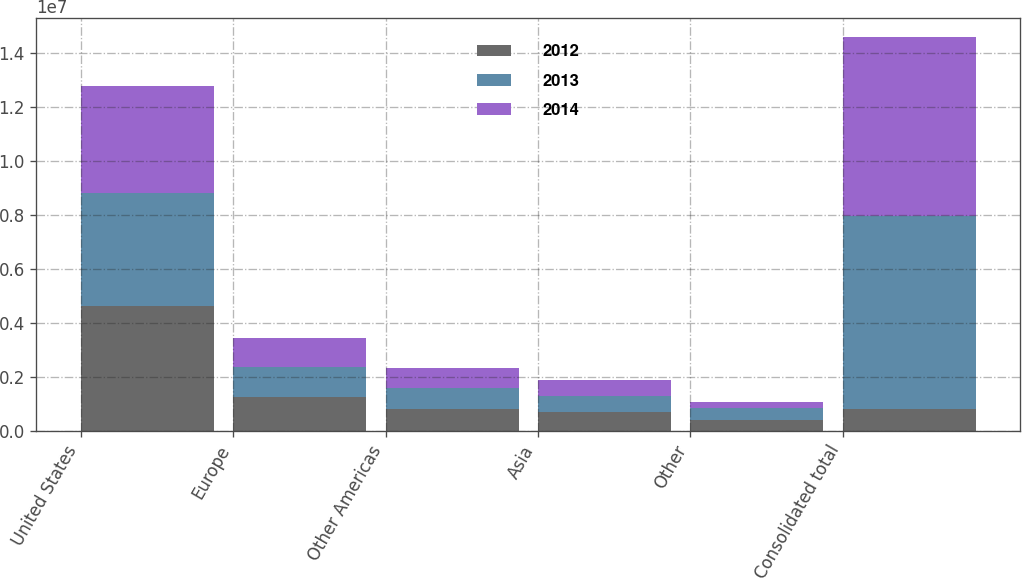Convert chart to OTSL. <chart><loc_0><loc_0><loc_500><loc_500><stacked_bar_chart><ecel><fcel>United States<fcel>Europe<fcel>Other Americas<fcel>Asia<fcel>Other<fcel>Consolidated total<nl><fcel>2012<fcel>4.61781e+06<fcel>1.25162e+06<fcel>794966<fcel>686511<fcel>401813<fcel>803741<nl><fcel>2013<fcel>4.20243e+06<fcel>1.11228e+06<fcel>803741<fcel>607873<fcel>428769<fcel>7.1551e+06<nl><fcel>2014<fcel>3.97792e+06<fcel>1.08221e+06<fcel>744192<fcel>574140<fcel>248181<fcel>6.62665e+06<nl></chart> 